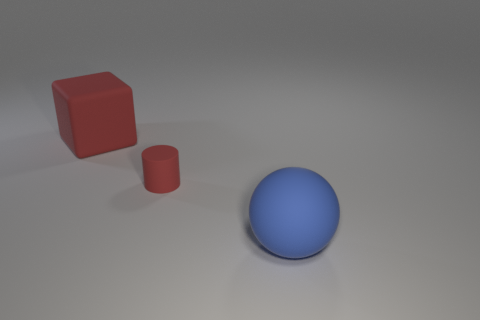Is there any other thing that is the same size as the rubber cylinder?
Give a very brief answer. No. What number of other things are the same size as the red rubber cylinder?
Provide a short and direct response. 0. The blue object is what size?
Give a very brief answer. Large. How many large red cubes are left of the rubber thing left of the small red thing?
Offer a very short reply. 0. Is the material of the large object that is behind the large matte sphere the same as the thing that is in front of the red cylinder?
Ensure brevity in your answer.  Yes. What number of other matte things have the same shape as the large red rubber object?
Ensure brevity in your answer.  0. What number of other rubber objects are the same color as the small thing?
Make the answer very short. 1. Does the large rubber thing that is in front of the big block have the same shape as the red thing in front of the large red object?
Keep it short and to the point. No. There is a red rubber thing to the right of the red object on the left side of the red cylinder; how many large objects are in front of it?
Your response must be concise. 1. What is the material of the big object in front of the big thing that is behind the large rubber object on the right side of the small red matte thing?
Ensure brevity in your answer.  Rubber. 